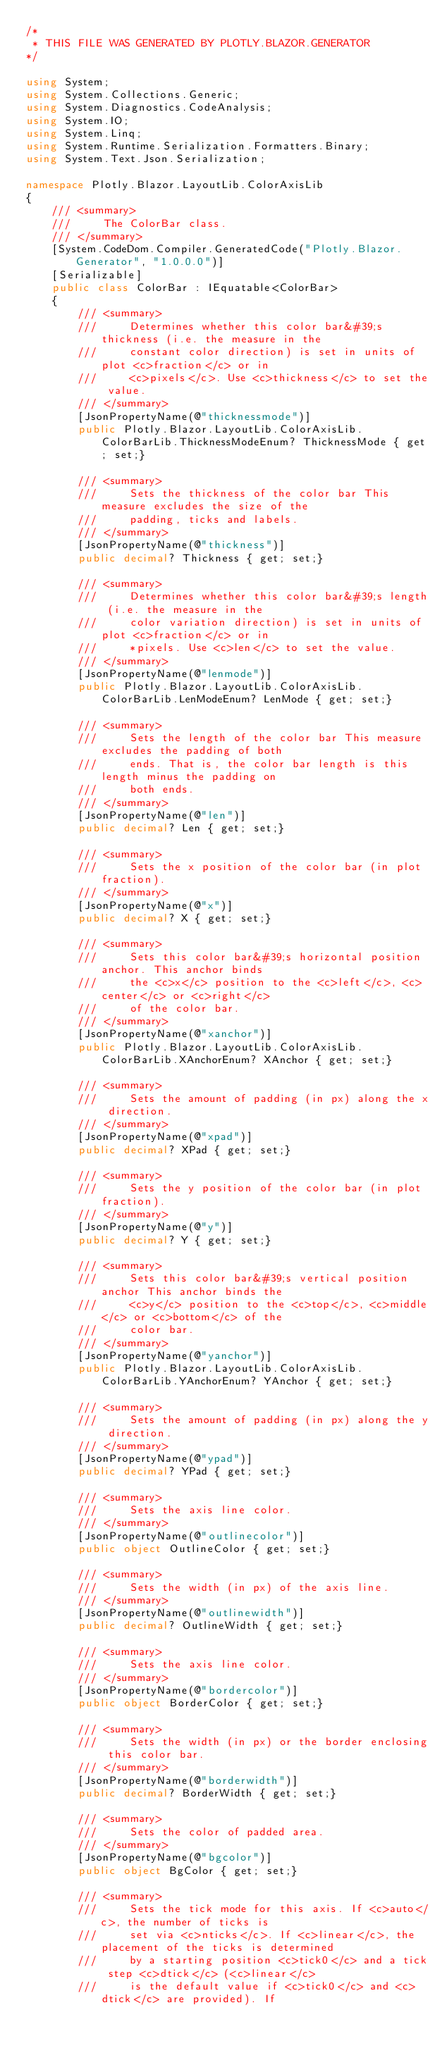<code> <loc_0><loc_0><loc_500><loc_500><_C#_>/*
 * THIS FILE WAS GENERATED BY PLOTLY.BLAZOR.GENERATOR
*/

using System;
using System.Collections.Generic;
using System.Diagnostics.CodeAnalysis;
using System.IO;
using System.Linq;
using System.Runtime.Serialization.Formatters.Binary;
using System.Text.Json.Serialization;

namespace Plotly.Blazor.LayoutLib.ColorAxisLib
{
    /// <summary>
    ///     The ColorBar class.
    /// </summary>
    [System.CodeDom.Compiler.GeneratedCode("Plotly.Blazor.Generator", "1.0.0.0")]
    [Serializable]
    public class ColorBar : IEquatable<ColorBar>
    {
        /// <summary>
        ///     Determines whether this color bar&#39;s thickness (i.e. the measure in the
        ///     constant color direction) is set in units of plot <c>fraction</c> or in
        ///     <c>pixels</c>. Use <c>thickness</c> to set the value.
        /// </summary>
        [JsonPropertyName(@"thicknessmode")]
        public Plotly.Blazor.LayoutLib.ColorAxisLib.ColorBarLib.ThicknessModeEnum? ThicknessMode { get; set;} 

        /// <summary>
        ///     Sets the thickness of the color bar This measure excludes the size of the
        ///     padding, ticks and labels.
        /// </summary>
        [JsonPropertyName(@"thickness")]
        public decimal? Thickness { get; set;} 

        /// <summary>
        ///     Determines whether this color bar&#39;s length (i.e. the measure in the
        ///     color variation direction) is set in units of plot <c>fraction</c> or in
        ///     *pixels. Use <c>len</c> to set the value.
        /// </summary>
        [JsonPropertyName(@"lenmode")]
        public Plotly.Blazor.LayoutLib.ColorAxisLib.ColorBarLib.LenModeEnum? LenMode { get; set;} 

        /// <summary>
        ///     Sets the length of the color bar This measure excludes the padding of both
        ///     ends. That is, the color bar length is this length minus the padding on
        ///     both ends.
        /// </summary>
        [JsonPropertyName(@"len")]
        public decimal? Len { get; set;} 

        /// <summary>
        ///     Sets the x position of the color bar (in plot fraction).
        /// </summary>
        [JsonPropertyName(@"x")]
        public decimal? X { get; set;} 

        /// <summary>
        ///     Sets this color bar&#39;s horizontal position anchor. This anchor binds
        ///     the <c>x</c> position to the <c>left</c>, <c>center</c> or <c>right</c>
        ///     of the color bar.
        /// </summary>
        [JsonPropertyName(@"xanchor")]
        public Plotly.Blazor.LayoutLib.ColorAxisLib.ColorBarLib.XAnchorEnum? XAnchor { get; set;} 

        /// <summary>
        ///     Sets the amount of padding (in px) along the x direction.
        /// </summary>
        [JsonPropertyName(@"xpad")]
        public decimal? XPad { get; set;} 

        /// <summary>
        ///     Sets the y position of the color bar (in plot fraction).
        /// </summary>
        [JsonPropertyName(@"y")]
        public decimal? Y { get; set;} 

        /// <summary>
        ///     Sets this color bar&#39;s vertical position anchor This anchor binds the
        ///     <c>y</c> position to the <c>top</c>, <c>middle</c> or <c>bottom</c> of the
        ///     color bar.
        /// </summary>
        [JsonPropertyName(@"yanchor")]
        public Plotly.Blazor.LayoutLib.ColorAxisLib.ColorBarLib.YAnchorEnum? YAnchor { get; set;} 

        /// <summary>
        ///     Sets the amount of padding (in px) along the y direction.
        /// </summary>
        [JsonPropertyName(@"ypad")]
        public decimal? YPad { get; set;} 

        /// <summary>
        ///     Sets the axis line color.
        /// </summary>
        [JsonPropertyName(@"outlinecolor")]
        public object OutlineColor { get; set;} 

        /// <summary>
        ///     Sets the width (in px) of the axis line.
        /// </summary>
        [JsonPropertyName(@"outlinewidth")]
        public decimal? OutlineWidth { get; set;} 

        /// <summary>
        ///     Sets the axis line color.
        /// </summary>
        [JsonPropertyName(@"bordercolor")]
        public object BorderColor { get; set;} 

        /// <summary>
        ///     Sets the width (in px) or the border enclosing this color bar.
        /// </summary>
        [JsonPropertyName(@"borderwidth")]
        public decimal? BorderWidth { get; set;} 

        /// <summary>
        ///     Sets the color of padded area.
        /// </summary>
        [JsonPropertyName(@"bgcolor")]
        public object BgColor { get; set;} 

        /// <summary>
        ///     Sets the tick mode for this axis. If <c>auto</c>, the number of ticks is
        ///     set via <c>nticks</c>. If <c>linear</c>, the placement of the ticks is determined
        ///     by a starting position <c>tick0</c> and a tick step <c>dtick</c> (<c>linear</c>
        ///     is the default value if <c>tick0</c> and <c>dtick</c> are provided). If</code> 